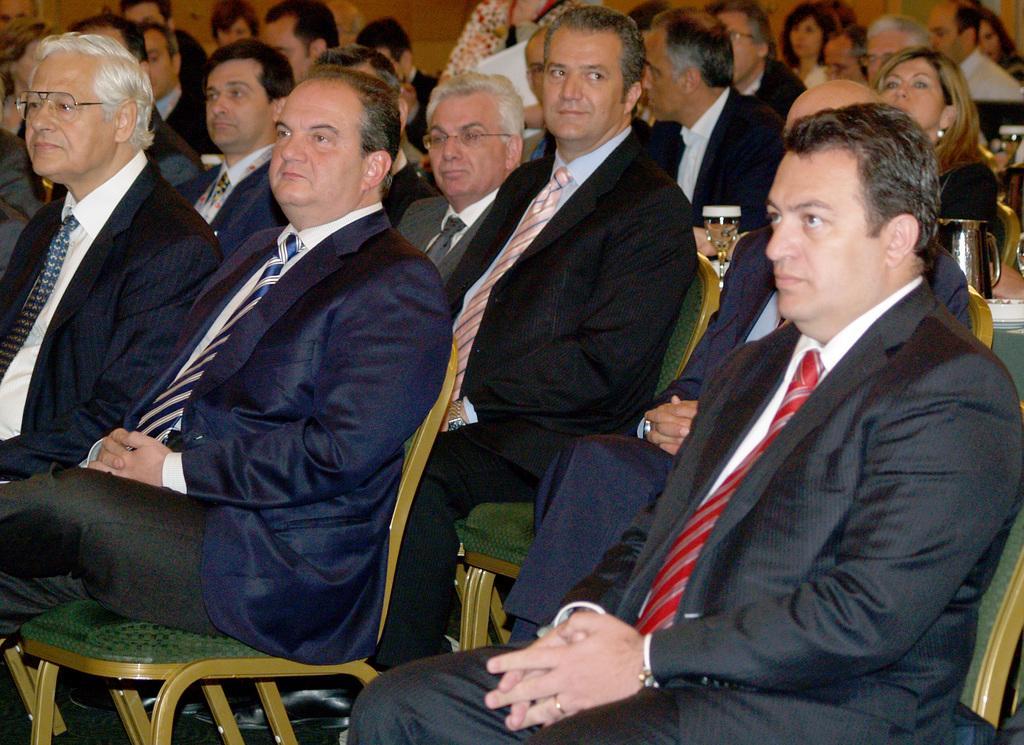Could you give a brief overview of what you see in this image? In this image we can see a crowd sitting on the chairs and a table is placed in between them. On the table we can see jug and a glass tumbler with beverage in it. 